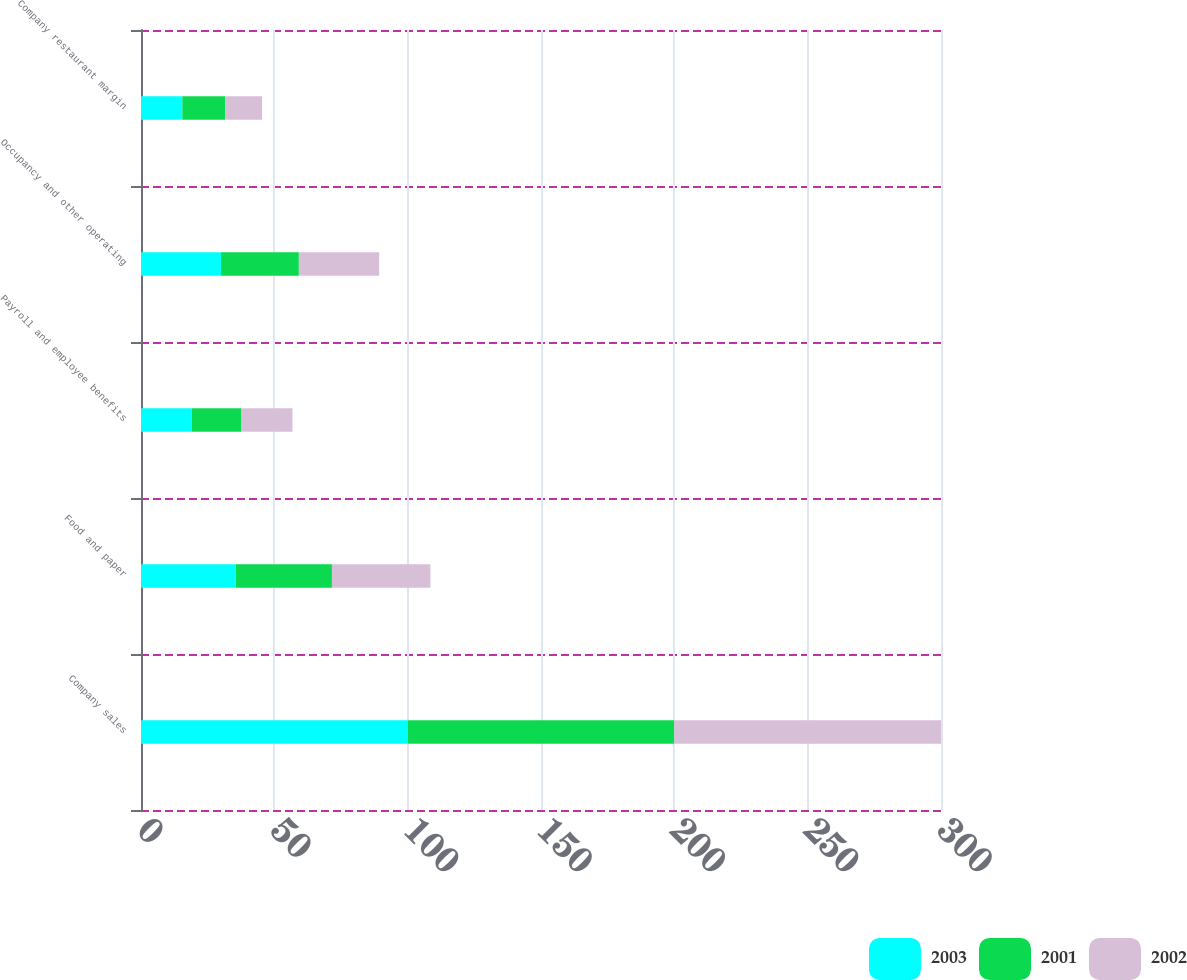<chart> <loc_0><loc_0><loc_500><loc_500><stacked_bar_chart><ecel><fcel>Company sales<fcel>Food and paper<fcel>Payroll and employee benefits<fcel>Occupancy and other operating<fcel>Company restaurant margin<nl><fcel>2003<fcel>100<fcel>35.5<fcel>19<fcel>30<fcel>15.5<nl><fcel>2001<fcel>100<fcel>36.1<fcel>18.7<fcel>29.2<fcel>16<nl><fcel>2002<fcel>100<fcel>36.9<fcel>19.1<fcel>30.1<fcel>13.9<nl></chart> 